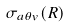<formula> <loc_0><loc_0><loc_500><loc_500>\sigma _ { a \theta v } ( R )</formula> 